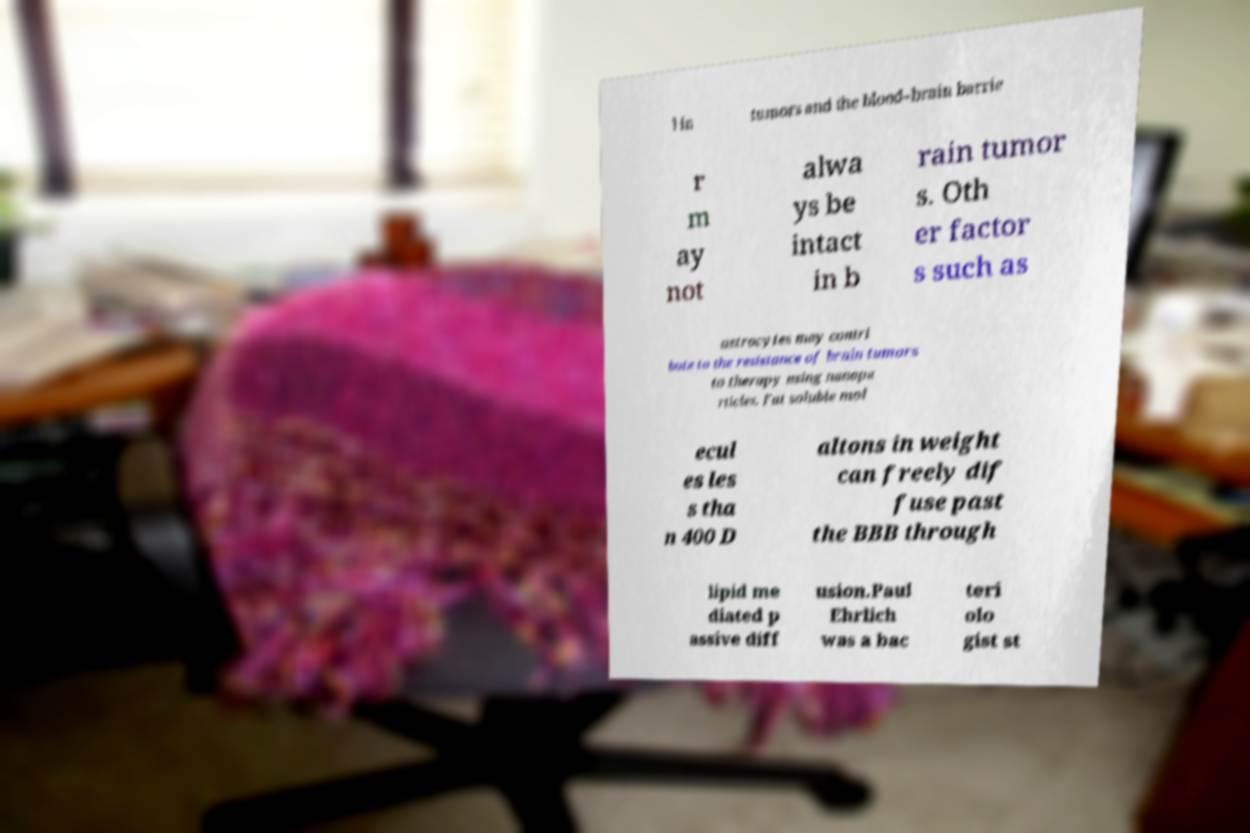Please identify and transcribe the text found in this image. l in tumors and the blood–brain barrie r m ay not alwa ys be intact in b rain tumor s. Oth er factor s such as astrocytes may contri bute to the resistance of brain tumors to therapy using nanopa rticles. Fat soluble mol ecul es les s tha n 400 D altons in weight can freely dif fuse past the BBB through lipid me diated p assive diff usion.Paul Ehrlich was a bac teri olo gist st 